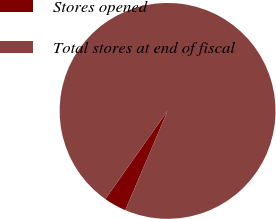Convert chart to OTSL. <chart><loc_0><loc_0><loc_500><loc_500><pie_chart><fcel>Stores opened<fcel>Total stores at end of fiscal<nl><fcel>3.36%<fcel>96.64%<nl></chart> 